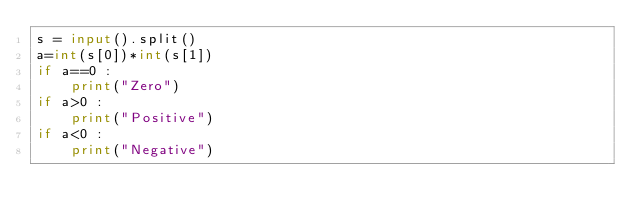Convert code to text. <code><loc_0><loc_0><loc_500><loc_500><_Python_>s = input().split()
a=int(s[0])*int(s[1])
if a==0 :
    print("Zero")
if a>0 :
    print("Positive")
if a<0 :
    print("Negative")
</code> 